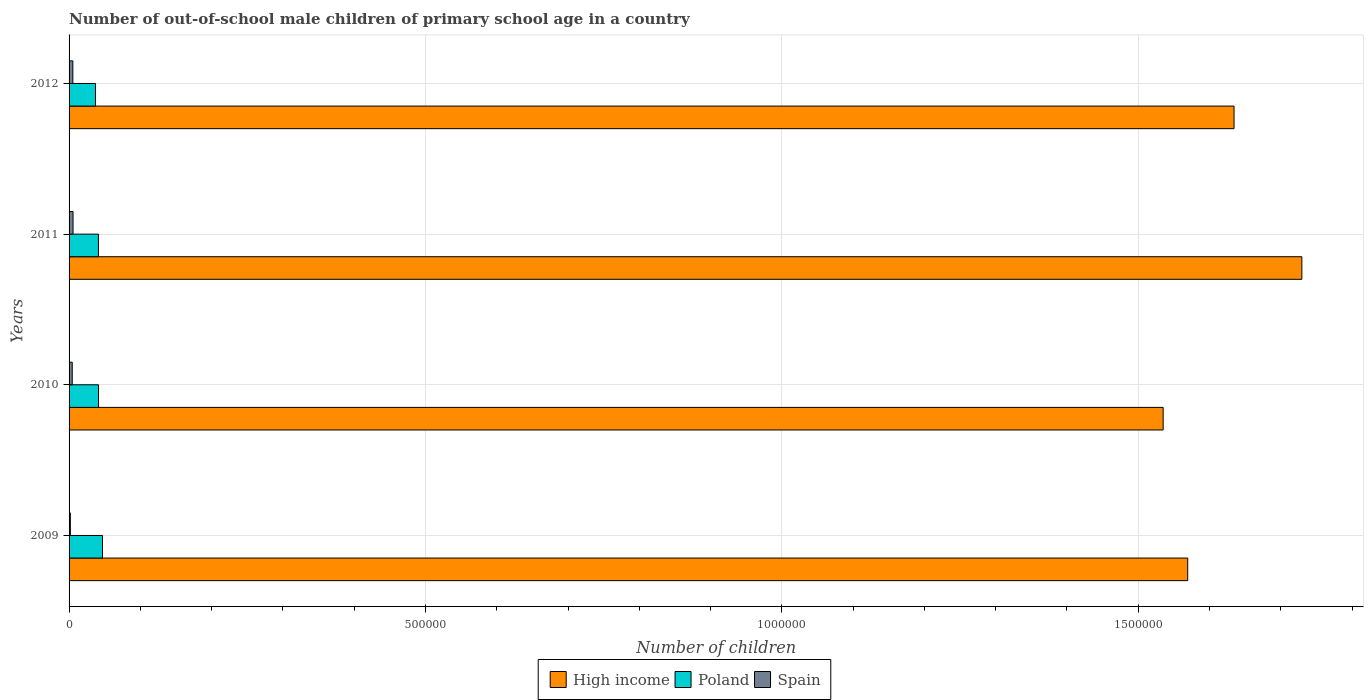How many groups of bars are there?
Make the answer very short. 4. Are the number of bars on each tick of the Y-axis equal?
Make the answer very short. Yes. How many bars are there on the 2nd tick from the bottom?
Offer a terse response. 3. What is the label of the 1st group of bars from the top?
Your response must be concise. 2012. What is the number of out-of-school male children in Poland in 2012?
Ensure brevity in your answer.  3.71e+04. Across all years, what is the maximum number of out-of-school male children in High income?
Offer a very short reply. 1.73e+06. Across all years, what is the minimum number of out-of-school male children in High income?
Keep it short and to the point. 1.53e+06. In which year was the number of out-of-school male children in Poland maximum?
Make the answer very short. 2009. In which year was the number of out-of-school male children in High income minimum?
Give a very brief answer. 2010. What is the total number of out-of-school male children in Poland in the graph?
Offer a very short reply. 1.67e+05. What is the difference between the number of out-of-school male children in Poland in 2010 and that in 2011?
Your answer should be compact. 103. What is the difference between the number of out-of-school male children in Spain in 2010 and the number of out-of-school male children in Poland in 2011?
Offer a terse response. -3.68e+04. What is the average number of out-of-school male children in High income per year?
Your answer should be very brief. 1.62e+06. In the year 2010, what is the difference between the number of out-of-school male children in Poland and number of out-of-school male children in Spain?
Your answer should be very brief. 3.69e+04. What is the ratio of the number of out-of-school male children in Spain in 2009 to that in 2010?
Make the answer very short. 0.41. Is the number of out-of-school male children in Spain in 2010 less than that in 2011?
Your response must be concise. Yes. What is the difference between the highest and the second highest number of out-of-school male children in Spain?
Ensure brevity in your answer.  261. What is the difference between the highest and the lowest number of out-of-school male children in Spain?
Give a very brief answer. 3748. In how many years, is the number of out-of-school male children in High income greater than the average number of out-of-school male children in High income taken over all years?
Give a very brief answer. 2. Is the sum of the number of out-of-school male children in Spain in 2011 and 2012 greater than the maximum number of out-of-school male children in Poland across all years?
Your answer should be compact. No. What does the 3rd bar from the bottom in 2012 represents?
Give a very brief answer. Spain. Are all the bars in the graph horizontal?
Give a very brief answer. Yes. What is the difference between two consecutive major ticks on the X-axis?
Offer a very short reply. 5.00e+05. Does the graph contain any zero values?
Your response must be concise. No. What is the title of the graph?
Provide a short and direct response. Number of out-of-school male children of primary school age in a country. What is the label or title of the X-axis?
Keep it short and to the point. Number of children. What is the label or title of the Y-axis?
Your answer should be very brief. Years. What is the Number of children of High income in 2009?
Make the answer very short. 1.57e+06. What is the Number of children of Poland in 2009?
Your answer should be very brief. 4.69e+04. What is the Number of children of Spain in 2009?
Give a very brief answer. 1807. What is the Number of children of High income in 2010?
Make the answer very short. 1.53e+06. What is the Number of children in Poland in 2010?
Your answer should be very brief. 4.13e+04. What is the Number of children in Spain in 2010?
Offer a very short reply. 4438. What is the Number of children of High income in 2011?
Provide a short and direct response. 1.73e+06. What is the Number of children of Poland in 2011?
Your answer should be very brief. 4.12e+04. What is the Number of children of Spain in 2011?
Keep it short and to the point. 5555. What is the Number of children in High income in 2012?
Make the answer very short. 1.63e+06. What is the Number of children in Poland in 2012?
Your answer should be compact. 3.71e+04. What is the Number of children of Spain in 2012?
Your response must be concise. 5294. Across all years, what is the maximum Number of children of High income?
Give a very brief answer. 1.73e+06. Across all years, what is the maximum Number of children of Poland?
Keep it short and to the point. 4.69e+04. Across all years, what is the maximum Number of children of Spain?
Offer a terse response. 5555. Across all years, what is the minimum Number of children of High income?
Keep it short and to the point. 1.53e+06. Across all years, what is the minimum Number of children of Poland?
Your response must be concise. 3.71e+04. Across all years, what is the minimum Number of children of Spain?
Offer a terse response. 1807. What is the total Number of children of High income in the graph?
Give a very brief answer. 6.47e+06. What is the total Number of children of Poland in the graph?
Provide a succinct answer. 1.67e+05. What is the total Number of children of Spain in the graph?
Offer a terse response. 1.71e+04. What is the difference between the Number of children in High income in 2009 and that in 2010?
Your response must be concise. 3.45e+04. What is the difference between the Number of children of Poland in 2009 and that in 2010?
Make the answer very short. 5557. What is the difference between the Number of children in Spain in 2009 and that in 2010?
Your answer should be very brief. -2631. What is the difference between the Number of children of High income in 2009 and that in 2011?
Keep it short and to the point. -1.60e+05. What is the difference between the Number of children of Poland in 2009 and that in 2011?
Provide a succinct answer. 5660. What is the difference between the Number of children of Spain in 2009 and that in 2011?
Offer a terse response. -3748. What is the difference between the Number of children of High income in 2009 and that in 2012?
Your answer should be very brief. -6.50e+04. What is the difference between the Number of children of Poland in 2009 and that in 2012?
Provide a short and direct response. 9743. What is the difference between the Number of children of Spain in 2009 and that in 2012?
Provide a short and direct response. -3487. What is the difference between the Number of children of High income in 2010 and that in 2011?
Ensure brevity in your answer.  -1.95e+05. What is the difference between the Number of children of Poland in 2010 and that in 2011?
Make the answer very short. 103. What is the difference between the Number of children of Spain in 2010 and that in 2011?
Offer a very short reply. -1117. What is the difference between the Number of children of High income in 2010 and that in 2012?
Your response must be concise. -9.95e+04. What is the difference between the Number of children in Poland in 2010 and that in 2012?
Make the answer very short. 4186. What is the difference between the Number of children in Spain in 2010 and that in 2012?
Give a very brief answer. -856. What is the difference between the Number of children in High income in 2011 and that in 2012?
Give a very brief answer. 9.51e+04. What is the difference between the Number of children of Poland in 2011 and that in 2012?
Your response must be concise. 4083. What is the difference between the Number of children in Spain in 2011 and that in 2012?
Your answer should be very brief. 261. What is the difference between the Number of children of High income in 2009 and the Number of children of Poland in 2010?
Keep it short and to the point. 1.53e+06. What is the difference between the Number of children of High income in 2009 and the Number of children of Spain in 2010?
Keep it short and to the point. 1.57e+06. What is the difference between the Number of children of Poland in 2009 and the Number of children of Spain in 2010?
Provide a short and direct response. 4.24e+04. What is the difference between the Number of children in High income in 2009 and the Number of children in Poland in 2011?
Your response must be concise. 1.53e+06. What is the difference between the Number of children of High income in 2009 and the Number of children of Spain in 2011?
Provide a succinct answer. 1.56e+06. What is the difference between the Number of children in Poland in 2009 and the Number of children in Spain in 2011?
Provide a succinct answer. 4.13e+04. What is the difference between the Number of children in High income in 2009 and the Number of children in Poland in 2012?
Your answer should be compact. 1.53e+06. What is the difference between the Number of children in High income in 2009 and the Number of children in Spain in 2012?
Your answer should be very brief. 1.56e+06. What is the difference between the Number of children of Poland in 2009 and the Number of children of Spain in 2012?
Your answer should be very brief. 4.16e+04. What is the difference between the Number of children in High income in 2010 and the Number of children in Poland in 2011?
Keep it short and to the point. 1.49e+06. What is the difference between the Number of children of High income in 2010 and the Number of children of Spain in 2011?
Make the answer very short. 1.53e+06. What is the difference between the Number of children in Poland in 2010 and the Number of children in Spain in 2011?
Your response must be concise. 3.58e+04. What is the difference between the Number of children of High income in 2010 and the Number of children of Poland in 2012?
Ensure brevity in your answer.  1.50e+06. What is the difference between the Number of children of High income in 2010 and the Number of children of Spain in 2012?
Provide a succinct answer. 1.53e+06. What is the difference between the Number of children in Poland in 2010 and the Number of children in Spain in 2012?
Ensure brevity in your answer.  3.60e+04. What is the difference between the Number of children in High income in 2011 and the Number of children in Poland in 2012?
Your answer should be very brief. 1.69e+06. What is the difference between the Number of children in High income in 2011 and the Number of children in Spain in 2012?
Provide a succinct answer. 1.72e+06. What is the difference between the Number of children in Poland in 2011 and the Number of children in Spain in 2012?
Provide a short and direct response. 3.59e+04. What is the average Number of children in High income per year?
Keep it short and to the point. 1.62e+06. What is the average Number of children in Poland per year?
Your answer should be very brief. 4.16e+04. What is the average Number of children in Spain per year?
Give a very brief answer. 4273.5. In the year 2009, what is the difference between the Number of children in High income and Number of children in Poland?
Your response must be concise. 1.52e+06. In the year 2009, what is the difference between the Number of children in High income and Number of children in Spain?
Your response must be concise. 1.57e+06. In the year 2009, what is the difference between the Number of children in Poland and Number of children in Spain?
Make the answer very short. 4.51e+04. In the year 2010, what is the difference between the Number of children of High income and Number of children of Poland?
Your answer should be compact. 1.49e+06. In the year 2010, what is the difference between the Number of children of High income and Number of children of Spain?
Offer a very short reply. 1.53e+06. In the year 2010, what is the difference between the Number of children in Poland and Number of children in Spain?
Your response must be concise. 3.69e+04. In the year 2011, what is the difference between the Number of children in High income and Number of children in Poland?
Ensure brevity in your answer.  1.69e+06. In the year 2011, what is the difference between the Number of children of High income and Number of children of Spain?
Your response must be concise. 1.72e+06. In the year 2011, what is the difference between the Number of children of Poland and Number of children of Spain?
Give a very brief answer. 3.57e+04. In the year 2012, what is the difference between the Number of children of High income and Number of children of Poland?
Your response must be concise. 1.60e+06. In the year 2012, what is the difference between the Number of children in High income and Number of children in Spain?
Provide a succinct answer. 1.63e+06. In the year 2012, what is the difference between the Number of children of Poland and Number of children of Spain?
Keep it short and to the point. 3.18e+04. What is the ratio of the Number of children in High income in 2009 to that in 2010?
Give a very brief answer. 1.02. What is the ratio of the Number of children of Poland in 2009 to that in 2010?
Provide a succinct answer. 1.13. What is the ratio of the Number of children in Spain in 2009 to that in 2010?
Provide a short and direct response. 0.41. What is the ratio of the Number of children in High income in 2009 to that in 2011?
Offer a very short reply. 0.91. What is the ratio of the Number of children in Poland in 2009 to that in 2011?
Offer a very short reply. 1.14. What is the ratio of the Number of children in Spain in 2009 to that in 2011?
Your answer should be very brief. 0.33. What is the ratio of the Number of children in High income in 2009 to that in 2012?
Your answer should be very brief. 0.96. What is the ratio of the Number of children in Poland in 2009 to that in 2012?
Your answer should be very brief. 1.26. What is the ratio of the Number of children of Spain in 2009 to that in 2012?
Offer a very short reply. 0.34. What is the ratio of the Number of children of High income in 2010 to that in 2011?
Offer a terse response. 0.89. What is the ratio of the Number of children in Spain in 2010 to that in 2011?
Give a very brief answer. 0.8. What is the ratio of the Number of children in High income in 2010 to that in 2012?
Provide a short and direct response. 0.94. What is the ratio of the Number of children in Poland in 2010 to that in 2012?
Your answer should be compact. 1.11. What is the ratio of the Number of children in Spain in 2010 to that in 2012?
Offer a terse response. 0.84. What is the ratio of the Number of children of High income in 2011 to that in 2012?
Your answer should be compact. 1.06. What is the ratio of the Number of children in Poland in 2011 to that in 2012?
Your answer should be very brief. 1.11. What is the ratio of the Number of children of Spain in 2011 to that in 2012?
Offer a terse response. 1.05. What is the difference between the highest and the second highest Number of children in High income?
Provide a short and direct response. 9.51e+04. What is the difference between the highest and the second highest Number of children of Poland?
Your answer should be very brief. 5557. What is the difference between the highest and the second highest Number of children of Spain?
Your answer should be compact. 261. What is the difference between the highest and the lowest Number of children in High income?
Offer a very short reply. 1.95e+05. What is the difference between the highest and the lowest Number of children in Poland?
Your answer should be very brief. 9743. What is the difference between the highest and the lowest Number of children of Spain?
Keep it short and to the point. 3748. 